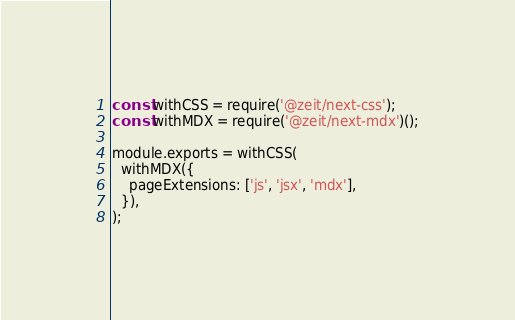<code> <loc_0><loc_0><loc_500><loc_500><_JavaScript_>const withCSS = require('@zeit/next-css');
const withMDX = require('@zeit/next-mdx')();

module.exports = withCSS(
  withMDX({
    pageExtensions: ['js', 'jsx', 'mdx'],
  }),
);
</code> 